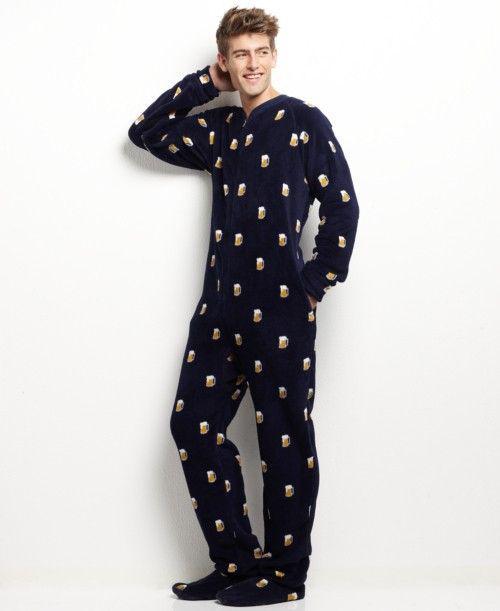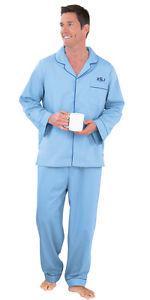The first image is the image on the left, the second image is the image on the right. Given the left and right images, does the statement "A model is wearing a one-piece pajama with an all-over print." hold true? Answer yes or no. Yes. 